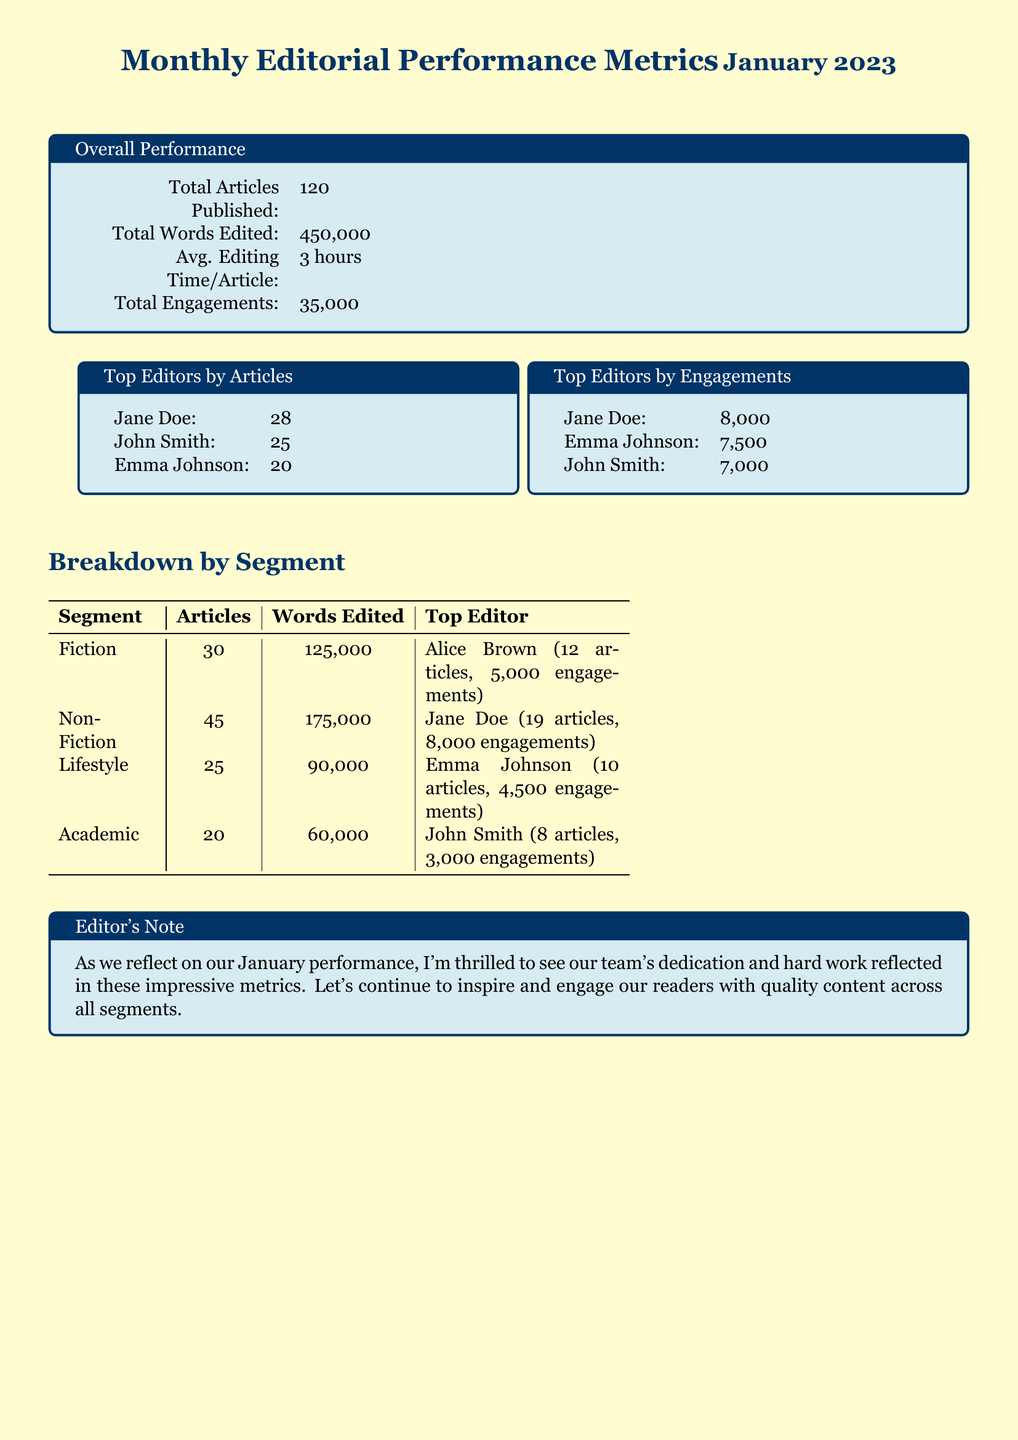what is the total number of articles published? The total number of articles published is stated in the overall performance section of the document.
Answer: 120 who is the top editor by articles published? The top editor by articles published can be found in the breakdown of top editors by articles.
Answer: Jane Doe how many total words were edited in January 2023? The total words edited is presented in the overall performance section.
Answer: 450,000 which segment had the fewest articles published? The segment with the fewest articles published can be determined from the breakdown by segment table.
Answer: Academic what is the total engagement for non-fiction articles? Total engagement for non-fiction is inferred by the top editor's engagements in that segment combined with the number of articles.
Answer: 8,000 how many average editing hours are spent per article? Average editing time per article is mentioned in the overall performance section.
Answer: 3 hours who edited the most articles in the fiction segment? The top editor in the fiction segment is specified in the breakdown by segment table.
Answer: Alice Brown what was the total engagement across all articles? Total engagements are summed up from the performance metrics presented at the beginning of the document.
Answer: 35,000 which editor had the highest engagement score? The top editor by engagements is listed in the top editors by engagements section.
Answer: Jane Doe 